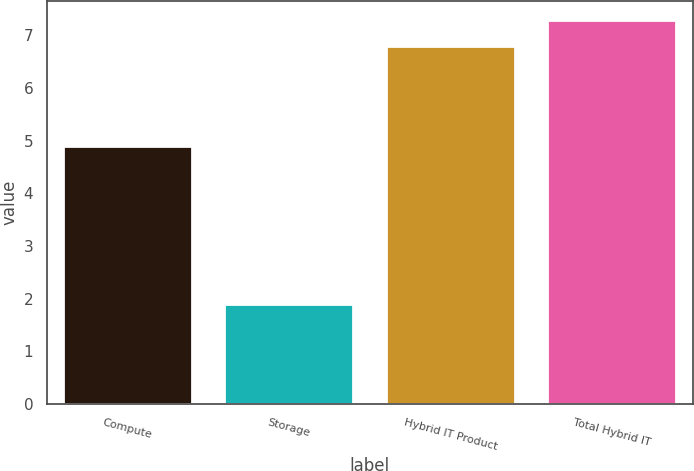<chart> <loc_0><loc_0><loc_500><loc_500><bar_chart><fcel>Compute<fcel>Storage<fcel>Hybrid IT Product<fcel>Total Hybrid IT<nl><fcel>4.9<fcel>1.9<fcel>6.8<fcel>7.29<nl></chart> 